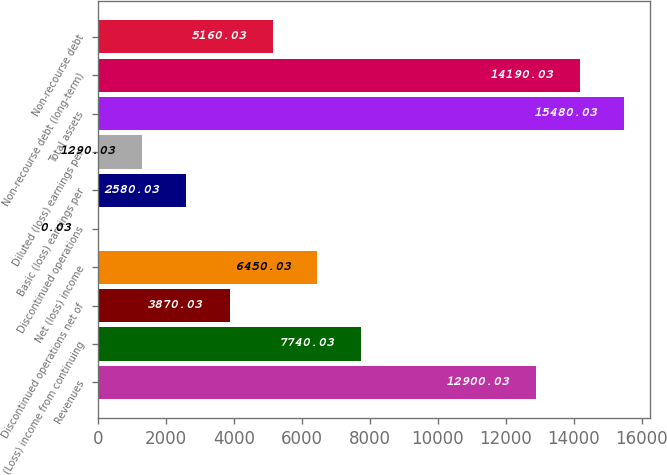<chart> <loc_0><loc_0><loc_500><loc_500><bar_chart><fcel>Revenues<fcel>(Loss) income from continuing<fcel>Discontinued operations net of<fcel>Net (loss) income<fcel>Discontinued operations<fcel>Basic (loss) earnings per<fcel>Diluted (loss) earnings per<fcel>Total assets<fcel>Non-recourse debt (long-term)<fcel>Non-recourse debt<nl><fcel>12900<fcel>7740.03<fcel>3870.03<fcel>6450.03<fcel>0.03<fcel>2580.03<fcel>1290.03<fcel>15480<fcel>14190<fcel>5160.03<nl></chart> 